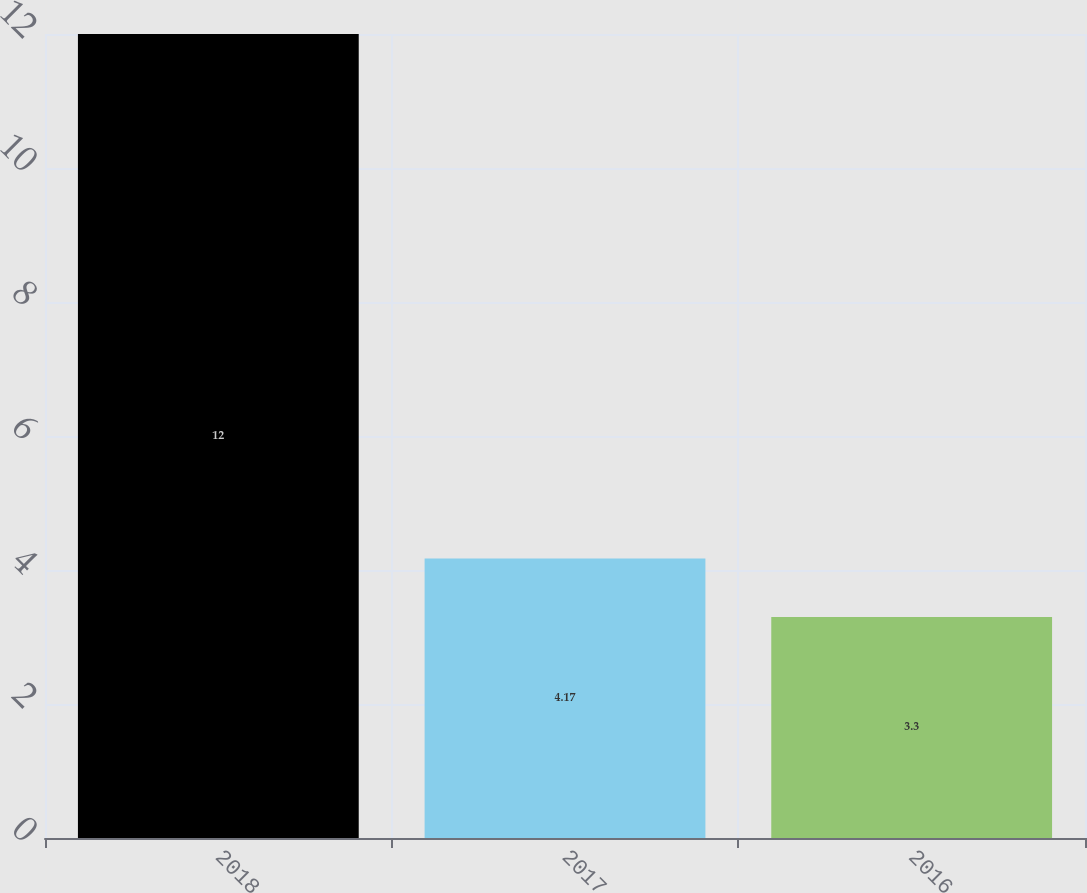<chart> <loc_0><loc_0><loc_500><loc_500><bar_chart><fcel>2018<fcel>2017<fcel>2016<nl><fcel>12<fcel>4.17<fcel>3.3<nl></chart> 